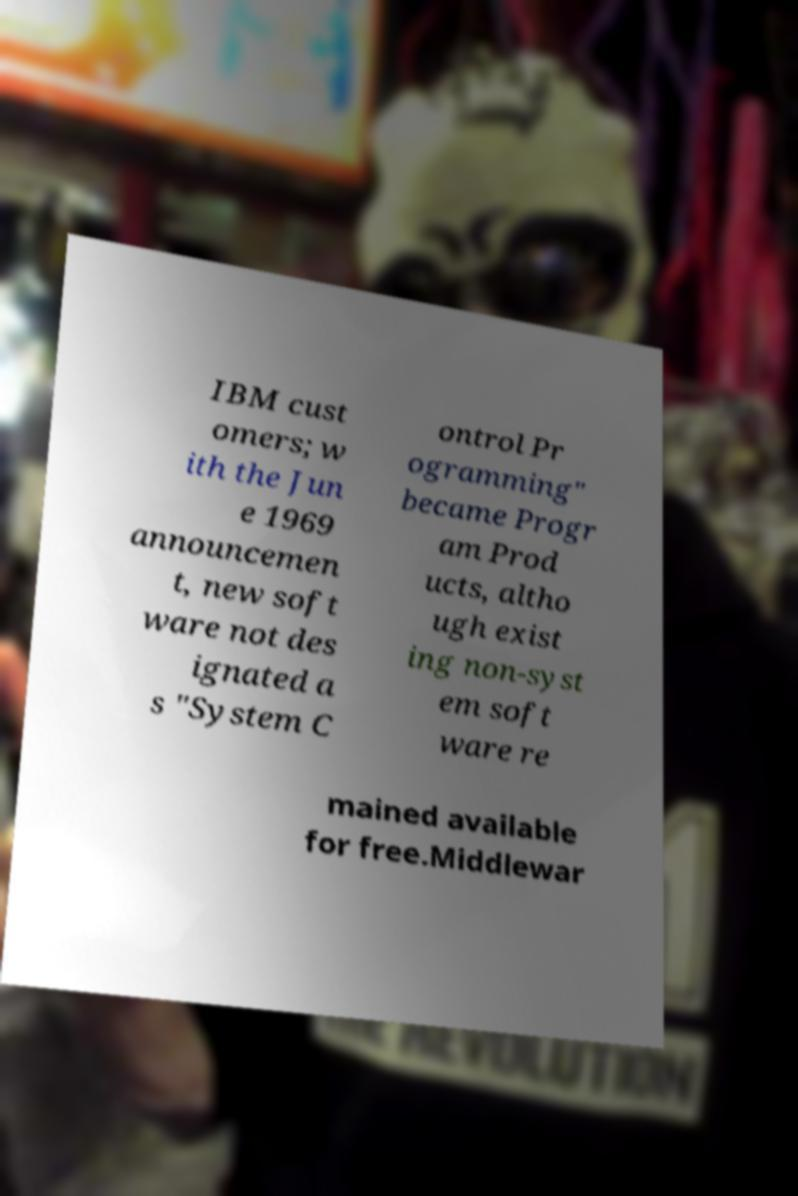Can you read and provide the text displayed in the image?This photo seems to have some interesting text. Can you extract and type it out for me? IBM cust omers; w ith the Jun e 1969 announcemen t, new soft ware not des ignated a s "System C ontrol Pr ogramming" became Progr am Prod ucts, altho ugh exist ing non-syst em soft ware re mained available for free.Middlewar 